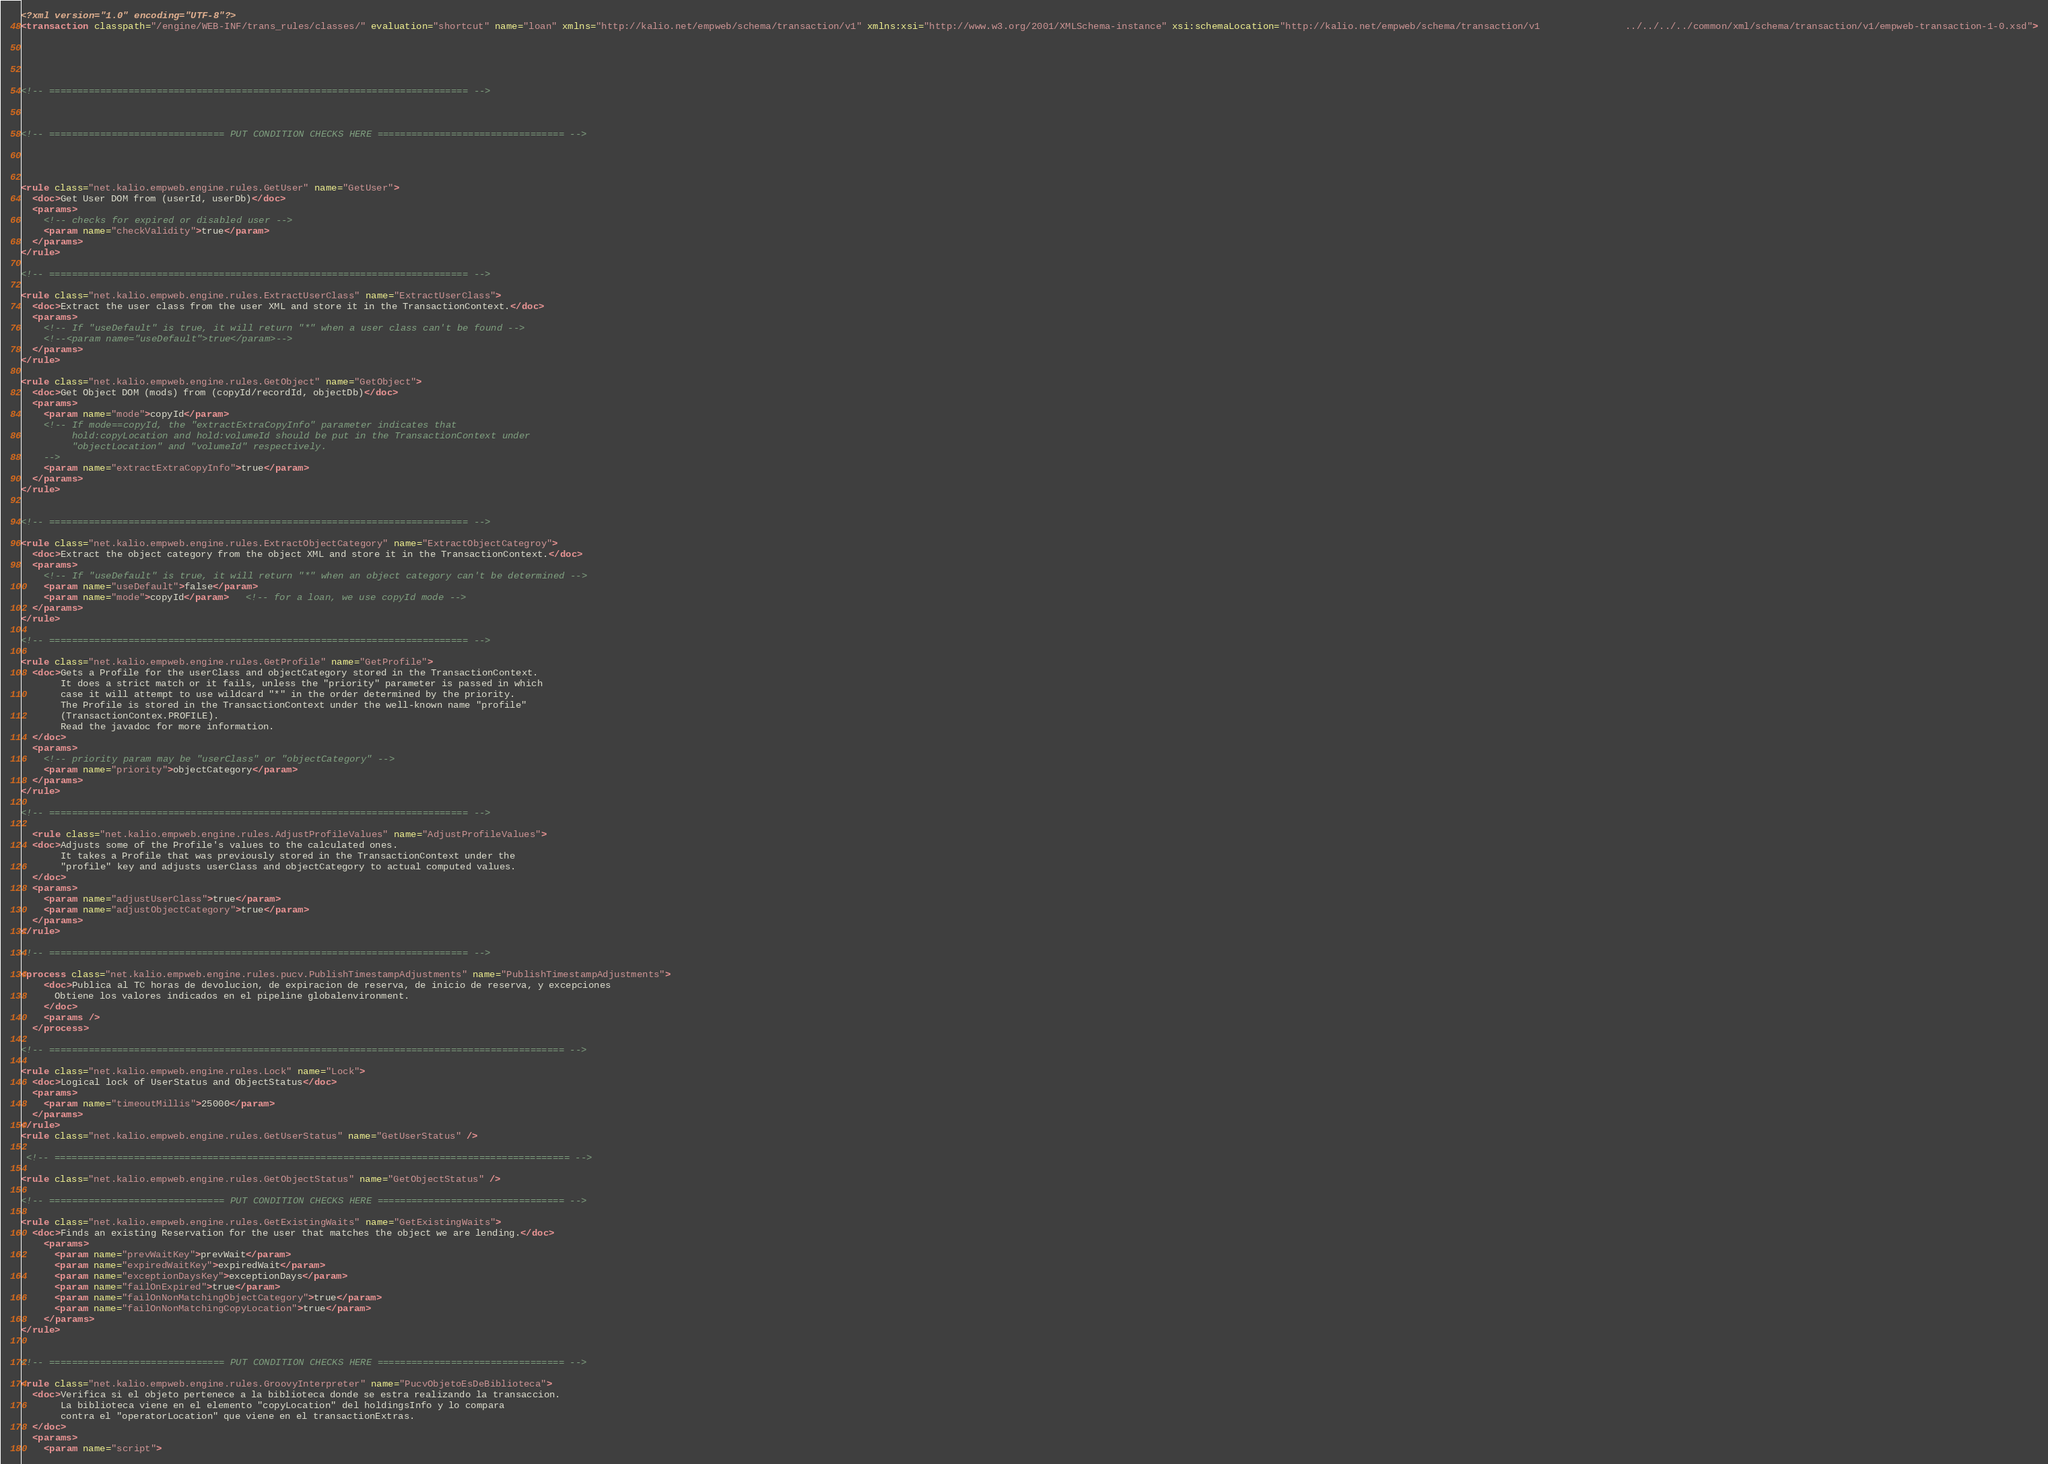Convert code to text. <code><loc_0><loc_0><loc_500><loc_500><_XML_><?xml version="1.0" encoding="UTF-8"?>
<transaction classpath="/engine/WEB-INF/trans_rules/classes/" evaluation="shortcut" name="loan" xmlns="http://kalio.net/empweb/schema/transaction/v1" xmlns:xsi="http://www.w3.org/2001/XMLSchema-instance" xsi:schemaLocation="http://kalio.net/empweb/schema/transaction/v1               ../../../../common/xml/schema/transaction/v1/empweb-transaction-1-0.xsd">





<!-- ========================================================================== -->



<!-- =============================== PUT CONDITION CHECKS HERE ================================= -->

  


<rule class="net.kalio.empweb.engine.rules.GetUser" name="GetUser">
  <doc>Get User DOM from (userId, userDb)</doc>
  <params>
    <!-- checks for expired or disabled user -->
    <param name="checkValidity">true</param>
  </params>
</rule>

<!-- ========================================================================== -->

<rule class="net.kalio.empweb.engine.rules.ExtractUserClass" name="ExtractUserClass">
  <doc>Extract the user class from the user XML and store it in the TransactionContext.</doc>
  <params>
    <!-- If "useDefault" is true, it will return "*" when a user class can't be found -->
    <!--<param name="useDefault">true</param>-->
  </params>
</rule>

<rule class="net.kalio.empweb.engine.rules.GetObject" name="GetObject">
  <doc>Get Object DOM (mods) from (copyId/recordId, objectDb)</doc>
  <params>
    <param name="mode">copyId</param>
    <!-- If mode==copyId, the "extractExtraCopyInfo" parameter indicates that
         hold:copyLocation and hold:volumeId should be put in the TransactionContext under
         "objectLocation" and "volumeId" respectively.
    -->
    <param name="extractExtraCopyInfo">true</param>
  </params>
</rule>


<!-- ========================================================================== -->

<rule class="net.kalio.empweb.engine.rules.ExtractObjectCategory" name="ExtractObjectCategroy">
  <doc>Extract the object category from the object XML and store it in the TransactionContext.</doc>
  <params>
    <!-- If "useDefault" is true, it will return "*" when an object category can't be determined -->
    <param name="useDefault">false</param>
    <param name="mode">copyId</param>   <!-- for a loan, we use copyId mode -->
  </params>
</rule>

<!-- ========================================================================== -->

<rule class="net.kalio.empweb.engine.rules.GetProfile" name="GetProfile">
  <doc>Gets a Profile for the userClass and objectCategory stored in the TransactionContext.
       It does a strict match or it fails, unless the "priority" parameter is passed in which
       case it will attempt to use wildcard "*" in the order determined by the priority.
       The Profile is stored in the TransactionContext under the well-known name "profile"
       (TransactionContex.PROFILE).
       Read the javadoc for more information.
  </doc>
  <params>
    <!-- priority param may be "userClass" or "objectCategory" -->
    <param name="priority">objectCategory</param>
  </params>
</rule>

<!-- ========================================================================== -->

  <rule class="net.kalio.empweb.engine.rules.AdjustProfileValues" name="AdjustProfileValues">
  <doc>Adjusts some of the Profile's values to the calculated ones.
       It takes a Profile that was previously stored in the TransactionContext under the
       "profile" key and adjusts userClass and objectCategory to actual computed values.
  </doc>
  <params>
    <param name="adjustUserClass">true</param>
    <param name="adjustObjectCategory">true</param>
  </params>
</rule>

<!-- ========================================================================== -->

<process class="net.kalio.empweb.engine.rules.pucv.PublishTimestampAdjustments" name="PublishTimestampAdjustments">
    <doc>Publica al TC horas de devolucion, de expiracion de reserva, de inicio de reserva, y excepciones
      Obtiene los valores indicados en el pipeline globalenvironment.
    </doc>
    <params />
  </process>

<!-- =========================================================================================== -->

<rule class="net.kalio.empweb.engine.rules.Lock" name="Lock">
  <doc>Logical lock of UserStatus and ObjectStatus</doc>
  <params>
    <param name="timeoutMillis">25000</param>
  </params>
</rule>
<rule class="net.kalio.empweb.engine.rules.GetUserStatus" name="GetUserStatus" />

 <!-- =========================================================================================== -->

<rule class="net.kalio.empweb.engine.rules.GetObjectStatus" name="GetObjectStatus" />

<!-- =============================== PUT CONDITION CHECKS HERE ================================= -->

<rule class="net.kalio.empweb.engine.rules.GetExistingWaits" name="GetExistingWaits">
  <doc>Finds an existing Reservation for the user that matches the object we are lending.</doc>
    <params>
      <param name="prevWaitKey">prevWait</param>
      <param name="expiredWaitKey">expiredWait</param>
      <param name="exceptionDaysKey">exceptionDays</param>
      <param name="failOnExpired">true</param>
      <param name="failOnNonMatchingObjectCategory">true</param>
      <param name="failOnNonMatchingCopyLocation">true</param>
    </params>
</rule>


<!-- =============================== PUT CONDITION CHECKS HERE ================================= -->

<rule class="net.kalio.empweb.engine.rules.GroovyInterpreter" name="PucvObjetoEsDeBiblioteca">
  <doc>Verifica si el objeto pertenece a la biblioteca donde se estra realizando la transaccion.
       La biblioteca viene en el elemento "copyLocation" del holdingsInfo y lo compara
       contra el "operatorLocation" que viene en el transactionExtras.
  </doc>
  <params>
    <param name="script"></code> 